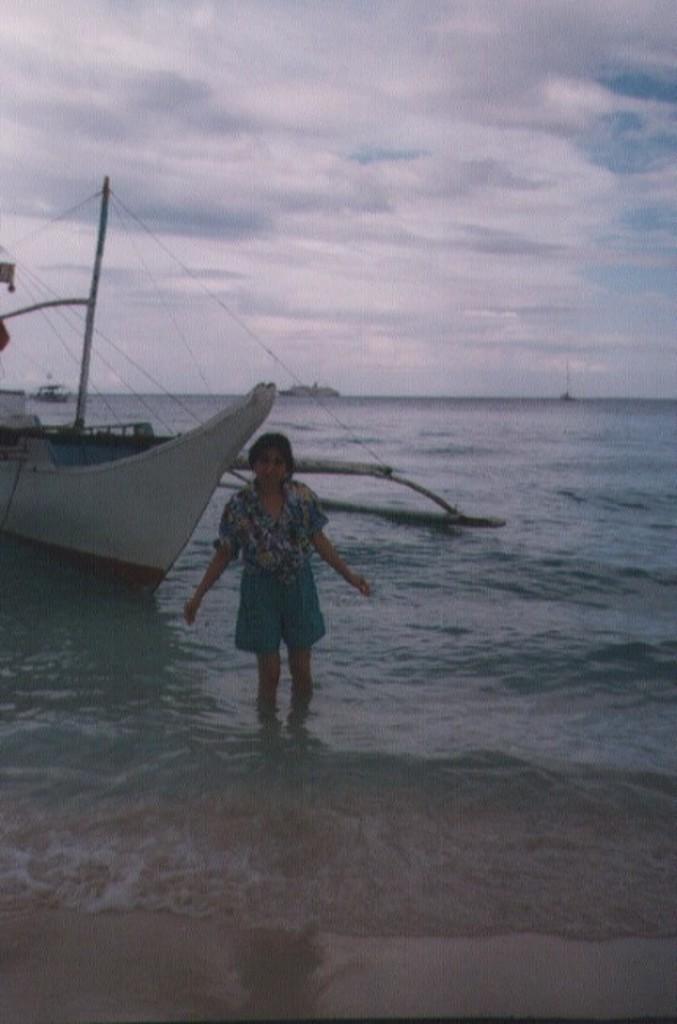In one or two sentences, can you explain what this image depicts? This picture is clicked outside. In the foreground we can see a person standing and we can see a boat and some other objects in the water body. In the background we can see the sky and the clouds. 